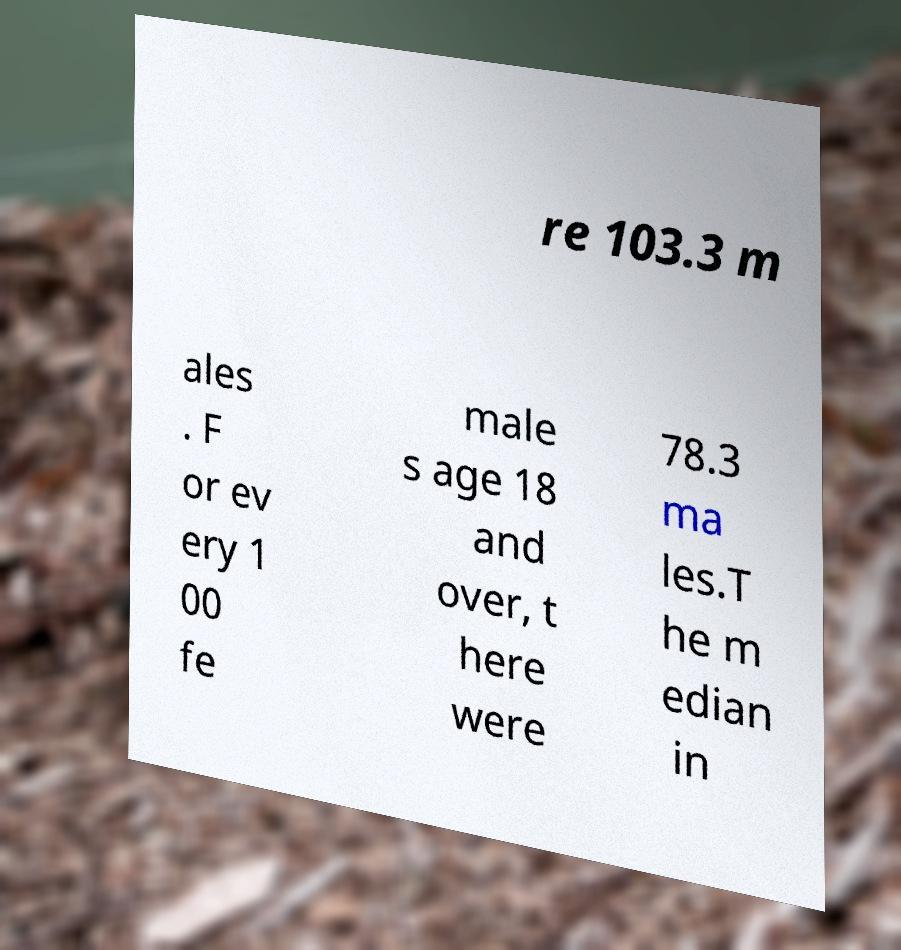I need the written content from this picture converted into text. Can you do that? re 103.3 m ales . F or ev ery 1 00 fe male s age 18 and over, t here were 78.3 ma les.T he m edian in 